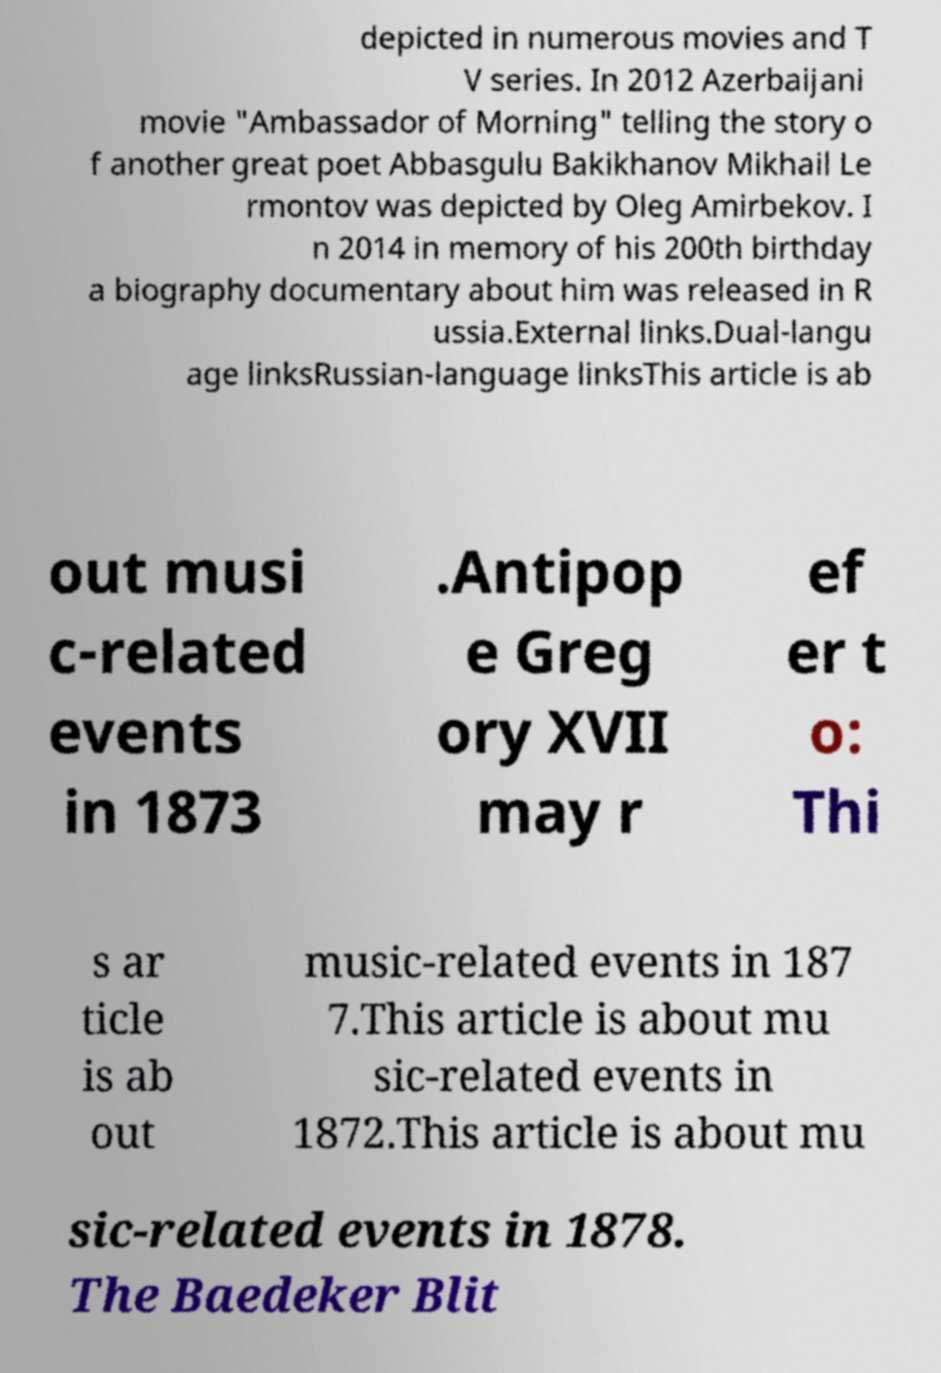Could you extract and type out the text from this image? depicted in numerous movies and T V series. In 2012 Azerbaijani movie "Ambassador of Morning" telling the story o f another great poet Abbasgulu Bakikhanov Mikhail Le rmontov was depicted by Oleg Amirbekov. I n 2014 in memory of his 200th birthday a biography documentary about him was released in R ussia.External links.Dual-langu age linksRussian-language linksThis article is ab out musi c-related events in 1873 .Antipop e Greg ory XVII may r ef er t o: Thi s ar ticle is ab out music-related events in 187 7.This article is about mu sic-related events in 1872.This article is about mu sic-related events in 1878. The Baedeker Blit 